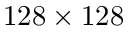Convert formula to latex. <formula><loc_0><loc_0><loc_500><loc_500>1 2 8 \times 1 2 8</formula> 